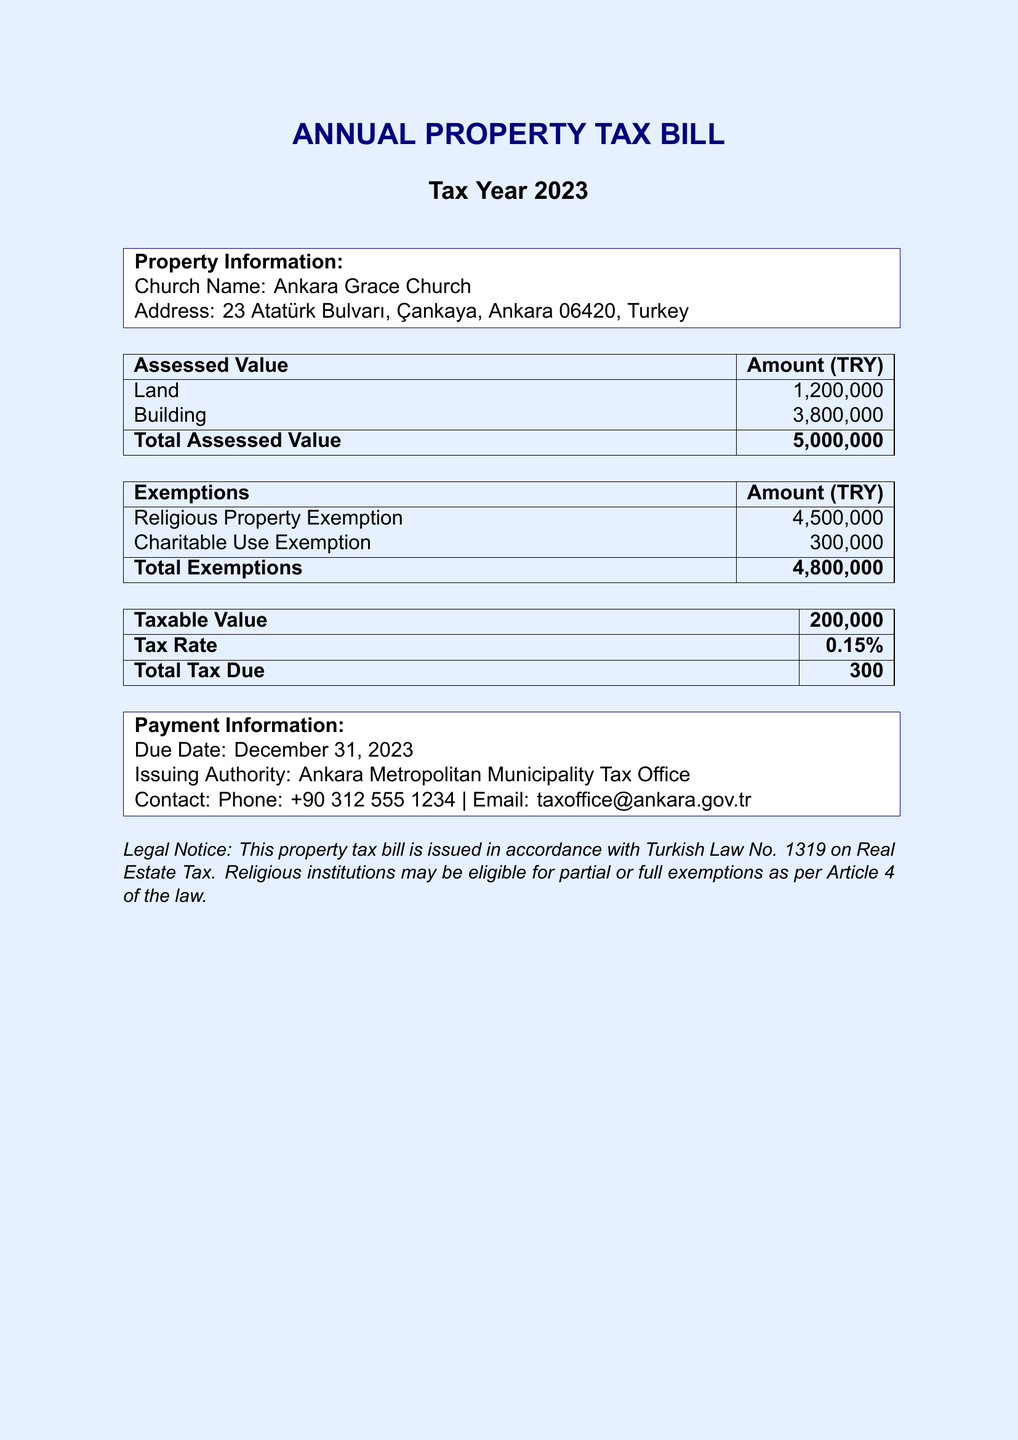What is the name of the church? The name of the church is mentioned under property information in the document.
Answer: Ankara Grace Church What is the total assessed value? The total assessed value is calculated by adding the land and building assessed values listed in the document.
Answer: 5,000,000 What is the amount of the religious property exemption? The religious property exemption is specified in the exemptions section of the document.
Answer: 4,500,000 What is the taxable value? The taxable value is listed in the tax section of the document and is derived after exemptions.
Answer: 200,000 What is the total tax due? The total tax due is stated in the tax section of the document and represents the final amount owed.
Answer: 300 What is the due date for the tax payment? The due date is provided in the payment information section of the document.
Answer: December 31, 2023 What is the contact email for the tax office? The contact email is found in the payment information section of the document.
Answer: taxoffice@ankara.gov.tr How much is the charitable use exemption? The charitable use exemption is specified in the document under the exemptions.
Answer: 300,000 What is the tax rate? The tax rate is indicated in the tax section of the document.
Answer: 0.15% 